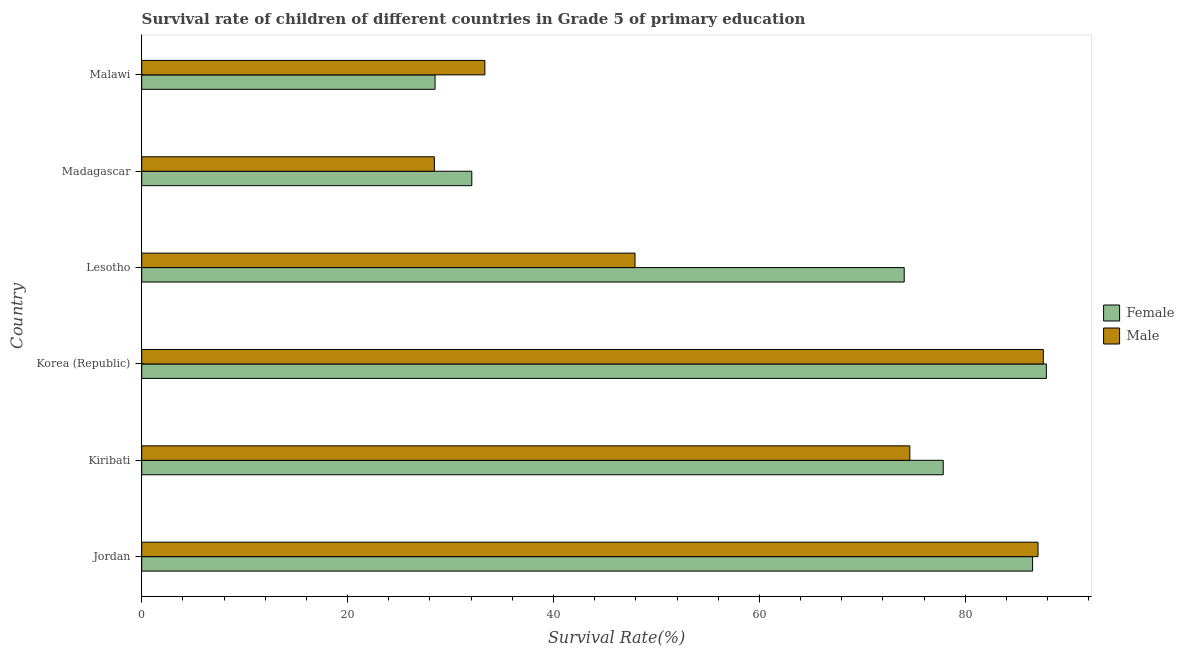How many groups of bars are there?
Ensure brevity in your answer.  6. What is the label of the 1st group of bars from the top?
Offer a terse response. Malawi. What is the survival rate of male students in primary education in Lesotho?
Ensure brevity in your answer.  47.91. Across all countries, what is the maximum survival rate of male students in primary education?
Give a very brief answer. 87.58. Across all countries, what is the minimum survival rate of female students in primary education?
Make the answer very short. 28.49. In which country was the survival rate of female students in primary education minimum?
Make the answer very short. Malawi. What is the total survival rate of male students in primary education in the graph?
Your answer should be very brief. 358.91. What is the difference between the survival rate of female students in primary education in Jordan and that in Kiribati?
Make the answer very short. 8.68. What is the difference between the survival rate of female students in primary education in Jordan and the survival rate of male students in primary education in Lesotho?
Offer a very short reply. 38.62. What is the average survival rate of male students in primary education per country?
Offer a very short reply. 59.82. What is the difference between the survival rate of female students in primary education and survival rate of male students in primary education in Lesotho?
Provide a short and direct response. 26.15. In how many countries, is the survival rate of female students in primary education greater than 84 %?
Give a very brief answer. 2. What is the ratio of the survival rate of female students in primary education in Madagascar to that in Malawi?
Ensure brevity in your answer.  1.12. Is the survival rate of female students in primary education in Korea (Republic) less than that in Lesotho?
Provide a succinct answer. No. What is the difference between the highest and the second highest survival rate of female students in primary education?
Provide a succinct answer. 1.34. What is the difference between the highest and the lowest survival rate of male students in primary education?
Make the answer very short. 59.15. In how many countries, is the survival rate of female students in primary education greater than the average survival rate of female students in primary education taken over all countries?
Ensure brevity in your answer.  4. What does the 2nd bar from the top in Korea (Republic) represents?
Make the answer very short. Female. What does the 1st bar from the bottom in Lesotho represents?
Your answer should be compact. Female. How many bars are there?
Your answer should be compact. 12. How many countries are there in the graph?
Make the answer very short. 6. Are the values on the major ticks of X-axis written in scientific E-notation?
Provide a short and direct response. No. Does the graph contain any zero values?
Your answer should be compact. No. Where does the legend appear in the graph?
Provide a short and direct response. Center right. How many legend labels are there?
Make the answer very short. 2. What is the title of the graph?
Provide a short and direct response. Survival rate of children of different countries in Grade 5 of primary education. What is the label or title of the X-axis?
Keep it short and to the point. Survival Rate(%). What is the Survival Rate(%) of Female in Jordan?
Your response must be concise. 86.53. What is the Survival Rate(%) in Male in Jordan?
Give a very brief answer. 87.06. What is the Survival Rate(%) in Female in Kiribati?
Offer a terse response. 77.85. What is the Survival Rate(%) in Male in Kiribati?
Give a very brief answer. 74.61. What is the Survival Rate(%) in Female in Korea (Republic)?
Offer a very short reply. 87.87. What is the Survival Rate(%) in Male in Korea (Republic)?
Your response must be concise. 87.58. What is the Survival Rate(%) of Female in Lesotho?
Offer a terse response. 74.06. What is the Survival Rate(%) in Male in Lesotho?
Give a very brief answer. 47.91. What is the Survival Rate(%) of Female in Madagascar?
Keep it short and to the point. 32.06. What is the Survival Rate(%) of Male in Madagascar?
Give a very brief answer. 28.43. What is the Survival Rate(%) of Female in Malawi?
Ensure brevity in your answer.  28.49. What is the Survival Rate(%) of Male in Malawi?
Provide a succinct answer. 33.33. Across all countries, what is the maximum Survival Rate(%) of Female?
Offer a terse response. 87.87. Across all countries, what is the maximum Survival Rate(%) of Male?
Offer a very short reply. 87.58. Across all countries, what is the minimum Survival Rate(%) of Female?
Your answer should be very brief. 28.49. Across all countries, what is the minimum Survival Rate(%) in Male?
Provide a short and direct response. 28.43. What is the total Survival Rate(%) in Female in the graph?
Provide a short and direct response. 386.87. What is the total Survival Rate(%) of Male in the graph?
Offer a very short reply. 358.91. What is the difference between the Survival Rate(%) in Female in Jordan and that in Kiribati?
Give a very brief answer. 8.68. What is the difference between the Survival Rate(%) of Male in Jordan and that in Kiribati?
Ensure brevity in your answer.  12.45. What is the difference between the Survival Rate(%) of Female in Jordan and that in Korea (Republic)?
Make the answer very short. -1.34. What is the difference between the Survival Rate(%) of Male in Jordan and that in Korea (Republic)?
Give a very brief answer. -0.52. What is the difference between the Survival Rate(%) in Female in Jordan and that in Lesotho?
Offer a terse response. 12.47. What is the difference between the Survival Rate(%) of Male in Jordan and that in Lesotho?
Provide a succinct answer. 39.15. What is the difference between the Survival Rate(%) of Female in Jordan and that in Madagascar?
Give a very brief answer. 54.47. What is the difference between the Survival Rate(%) in Male in Jordan and that in Madagascar?
Give a very brief answer. 58.63. What is the difference between the Survival Rate(%) in Female in Jordan and that in Malawi?
Give a very brief answer. 58.04. What is the difference between the Survival Rate(%) in Male in Jordan and that in Malawi?
Your answer should be very brief. 53.73. What is the difference between the Survival Rate(%) in Female in Kiribati and that in Korea (Republic)?
Make the answer very short. -10.02. What is the difference between the Survival Rate(%) in Male in Kiribati and that in Korea (Republic)?
Your response must be concise. -12.97. What is the difference between the Survival Rate(%) in Female in Kiribati and that in Lesotho?
Your answer should be compact. 3.79. What is the difference between the Survival Rate(%) in Male in Kiribati and that in Lesotho?
Make the answer very short. 26.69. What is the difference between the Survival Rate(%) in Female in Kiribati and that in Madagascar?
Your answer should be compact. 45.79. What is the difference between the Survival Rate(%) in Male in Kiribati and that in Madagascar?
Your answer should be compact. 46.18. What is the difference between the Survival Rate(%) in Female in Kiribati and that in Malawi?
Keep it short and to the point. 49.36. What is the difference between the Survival Rate(%) of Male in Kiribati and that in Malawi?
Make the answer very short. 41.28. What is the difference between the Survival Rate(%) of Female in Korea (Republic) and that in Lesotho?
Ensure brevity in your answer.  13.81. What is the difference between the Survival Rate(%) in Male in Korea (Republic) and that in Lesotho?
Offer a very short reply. 39.66. What is the difference between the Survival Rate(%) in Female in Korea (Republic) and that in Madagascar?
Give a very brief answer. 55.81. What is the difference between the Survival Rate(%) in Male in Korea (Republic) and that in Madagascar?
Provide a short and direct response. 59.15. What is the difference between the Survival Rate(%) in Female in Korea (Republic) and that in Malawi?
Give a very brief answer. 59.38. What is the difference between the Survival Rate(%) of Male in Korea (Republic) and that in Malawi?
Ensure brevity in your answer.  54.25. What is the difference between the Survival Rate(%) in Female in Lesotho and that in Madagascar?
Ensure brevity in your answer.  42. What is the difference between the Survival Rate(%) of Male in Lesotho and that in Madagascar?
Give a very brief answer. 19.49. What is the difference between the Survival Rate(%) of Female in Lesotho and that in Malawi?
Provide a short and direct response. 45.57. What is the difference between the Survival Rate(%) in Male in Lesotho and that in Malawi?
Your response must be concise. 14.58. What is the difference between the Survival Rate(%) in Female in Madagascar and that in Malawi?
Offer a terse response. 3.57. What is the difference between the Survival Rate(%) of Male in Madagascar and that in Malawi?
Your response must be concise. -4.9. What is the difference between the Survival Rate(%) in Female in Jordan and the Survival Rate(%) in Male in Kiribati?
Provide a short and direct response. 11.93. What is the difference between the Survival Rate(%) of Female in Jordan and the Survival Rate(%) of Male in Korea (Republic)?
Provide a succinct answer. -1.04. What is the difference between the Survival Rate(%) of Female in Jordan and the Survival Rate(%) of Male in Lesotho?
Provide a succinct answer. 38.62. What is the difference between the Survival Rate(%) of Female in Jordan and the Survival Rate(%) of Male in Madagascar?
Your answer should be very brief. 58.1. What is the difference between the Survival Rate(%) in Female in Jordan and the Survival Rate(%) in Male in Malawi?
Ensure brevity in your answer.  53.2. What is the difference between the Survival Rate(%) in Female in Kiribati and the Survival Rate(%) in Male in Korea (Republic)?
Your answer should be compact. -9.72. What is the difference between the Survival Rate(%) in Female in Kiribati and the Survival Rate(%) in Male in Lesotho?
Provide a short and direct response. 29.94. What is the difference between the Survival Rate(%) in Female in Kiribati and the Survival Rate(%) in Male in Madagascar?
Your response must be concise. 49.42. What is the difference between the Survival Rate(%) in Female in Kiribati and the Survival Rate(%) in Male in Malawi?
Keep it short and to the point. 44.52. What is the difference between the Survival Rate(%) of Female in Korea (Republic) and the Survival Rate(%) of Male in Lesotho?
Provide a succinct answer. 39.95. What is the difference between the Survival Rate(%) of Female in Korea (Republic) and the Survival Rate(%) of Male in Madagascar?
Your answer should be compact. 59.44. What is the difference between the Survival Rate(%) of Female in Korea (Republic) and the Survival Rate(%) of Male in Malawi?
Make the answer very short. 54.54. What is the difference between the Survival Rate(%) in Female in Lesotho and the Survival Rate(%) in Male in Madagascar?
Your answer should be compact. 45.63. What is the difference between the Survival Rate(%) of Female in Lesotho and the Survival Rate(%) of Male in Malawi?
Make the answer very short. 40.73. What is the difference between the Survival Rate(%) in Female in Madagascar and the Survival Rate(%) in Male in Malawi?
Offer a very short reply. -1.27. What is the average Survival Rate(%) in Female per country?
Your response must be concise. 64.48. What is the average Survival Rate(%) in Male per country?
Offer a terse response. 59.82. What is the difference between the Survival Rate(%) in Female and Survival Rate(%) in Male in Jordan?
Make the answer very short. -0.53. What is the difference between the Survival Rate(%) of Female and Survival Rate(%) of Male in Kiribati?
Provide a succinct answer. 3.25. What is the difference between the Survival Rate(%) in Female and Survival Rate(%) in Male in Korea (Republic)?
Keep it short and to the point. 0.29. What is the difference between the Survival Rate(%) of Female and Survival Rate(%) of Male in Lesotho?
Ensure brevity in your answer.  26.15. What is the difference between the Survival Rate(%) in Female and Survival Rate(%) in Male in Madagascar?
Ensure brevity in your answer.  3.63. What is the difference between the Survival Rate(%) of Female and Survival Rate(%) of Male in Malawi?
Keep it short and to the point. -4.84. What is the ratio of the Survival Rate(%) of Female in Jordan to that in Kiribati?
Your response must be concise. 1.11. What is the ratio of the Survival Rate(%) of Male in Jordan to that in Kiribati?
Provide a short and direct response. 1.17. What is the ratio of the Survival Rate(%) of Female in Jordan to that in Lesotho?
Ensure brevity in your answer.  1.17. What is the ratio of the Survival Rate(%) of Male in Jordan to that in Lesotho?
Ensure brevity in your answer.  1.82. What is the ratio of the Survival Rate(%) of Female in Jordan to that in Madagascar?
Offer a very short reply. 2.7. What is the ratio of the Survival Rate(%) of Male in Jordan to that in Madagascar?
Your answer should be very brief. 3.06. What is the ratio of the Survival Rate(%) of Female in Jordan to that in Malawi?
Your answer should be compact. 3.04. What is the ratio of the Survival Rate(%) of Male in Jordan to that in Malawi?
Make the answer very short. 2.61. What is the ratio of the Survival Rate(%) of Female in Kiribati to that in Korea (Republic)?
Make the answer very short. 0.89. What is the ratio of the Survival Rate(%) in Male in Kiribati to that in Korea (Republic)?
Offer a terse response. 0.85. What is the ratio of the Survival Rate(%) of Female in Kiribati to that in Lesotho?
Your answer should be very brief. 1.05. What is the ratio of the Survival Rate(%) of Male in Kiribati to that in Lesotho?
Offer a terse response. 1.56. What is the ratio of the Survival Rate(%) in Female in Kiribati to that in Madagascar?
Keep it short and to the point. 2.43. What is the ratio of the Survival Rate(%) in Male in Kiribati to that in Madagascar?
Make the answer very short. 2.62. What is the ratio of the Survival Rate(%) in Female in Kiribati to that in Malawi?
Your response must be concise. 2.73. What is the ratio of the Survival Rate(%) of Male in Kiribati to that in Malawi?
Make the answer very short. 2.24. What is the ratio of the Survival Rate(%) of Female in Korea (Republic) to that in Lesotho?
Offer a very short reply. 1.19. What is the ratio of the Survival Rate(%) in Male in Korea (Republic) to that in Lesotho?
Your response must be concise. 1.83. What is the ratio of the Survival Rate(%) of Female in Korea (Republic) to that in Madagascar?
Your answer should be compact. 2.74. What is the ratio of the Survival Rate(%) in Male in Korea (Republic) to that in Madagascar?
Your response must be concise. 3.08. What is the ratio of the Survival Rate(%) of Female in Korea (Republic) to that in Malawi?
Keep it short and to the point. 3.08. What is the ratio of the Survival Rate(%) in Male in Korea (Republic) to that in Malawi?
Give a very brief answer. 2.63. What is the ratio of the Survival Rate(%) in Female in Lesotho to that in Madagascar?
Make the answer very short. 2.31. What is the ratio of the Survival Rate(%) in Male in Lesotho to that in Madagascar?
Provide a succinct answer. 1.69. What is the ratio of the Survival Rate(%) of Female in Lesotho to that in Malawi?
Provide a short and direct response. 2.6. What is the ratio of the Survival Rate(%) of Male in Lesotho to that in Malawi?
Offer a terse response. 1.44. What is the ratio of the Survival Rate(%) of Female in Madagascar to that in Malawi?
Your answer should be compact. 1.13. What is the ratio of the Survival Rate(%) of Male in Madagascar to that in Malawi?
Give a very brief answer. 0.85. What is the difference between the highest and the second highest Survival Rate(%) in Female?
Provide a succinct answer. 1.34. What is the difference between the highest and the second highest Survival Rate(%) of Male?
Ensure brevity in your answer.  0.52. What is the difference between the highest and the lowest Survival Rate(%) in Female?
Your response must be concise. 59.38. What is the difference between the highest and the lowest Survival Rate(%) of Male?
Offer a very short reply. 59.15. 